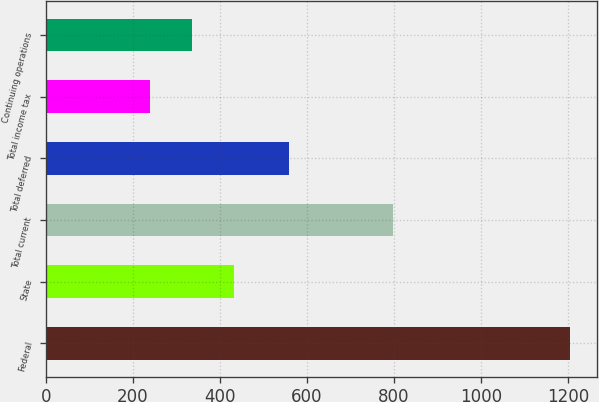Convert chart to OTSL. <chart><loc_0><loc_0><loc_500><loc_500><bar_chart><fcel>Federal<fcel>State<fcel>Total current<fcel>Total deferred<fcel>Total income tax<fcel>Continuing operations<nl><fcel>1205<fcel>433<fcel>798<fcel>558<fcel>240<fcel>336.5<nl></chart> 